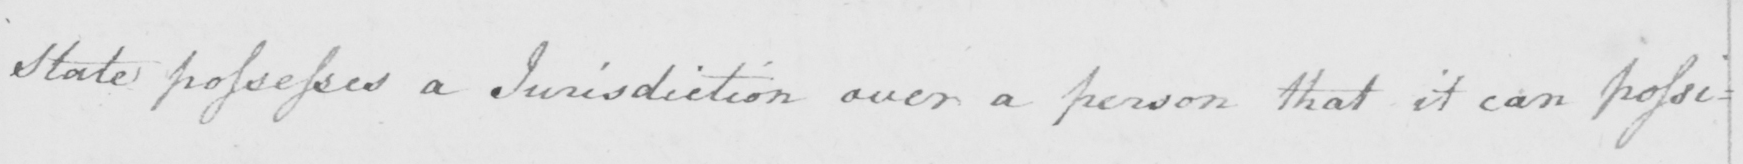Transcribe the text shown in this historical manuscript line. State possesses a Jurisdiction over a person that it can possi= 